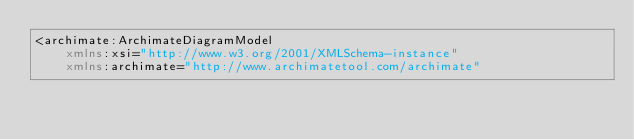Convert code to text. <code><loc_0><loc_0><loc_500><loc_500><_XML_><archimate:ArchimateDiagramModel
    xmlns:xsi="http://www.w3.org/2001/XMLSchema-instance"
    xmlns:archimate="http://www.archimatetool.com/archimate"</code> 